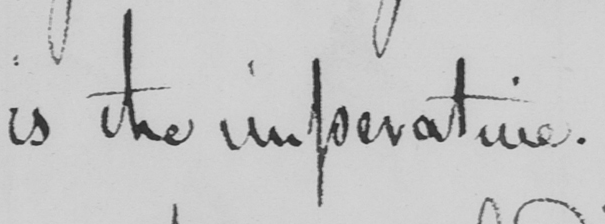Can you read and transcribe this handwriting? is the imperative . 